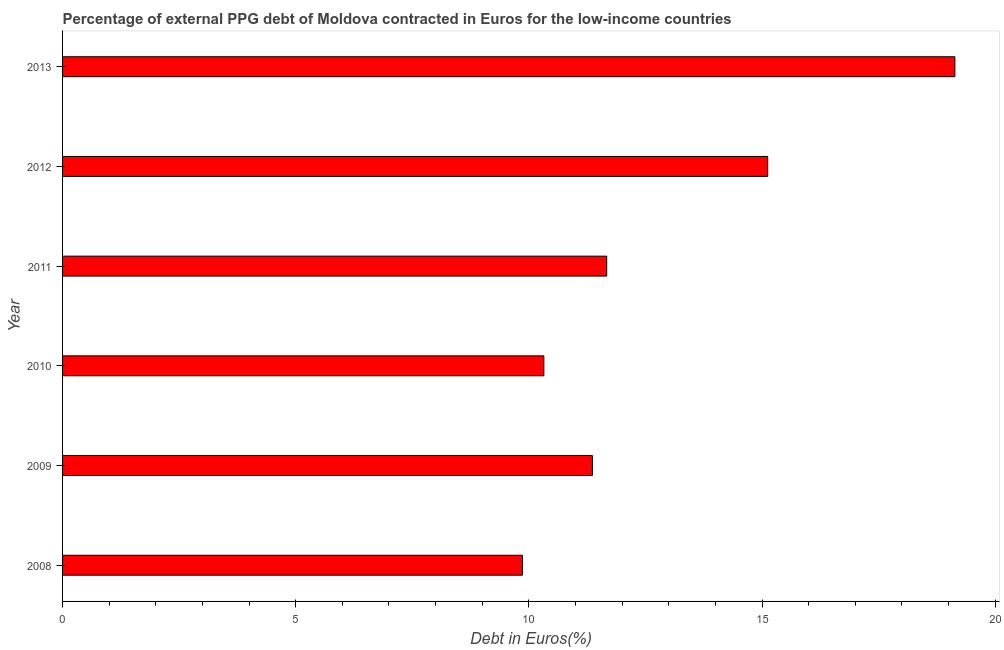Does the graph contain any zero values?
Your answer should be very brief. No. What is the title of the graph?
Your answer should be compact. Percentage of external PPG debt of Moldova contracted in Euros for the low-income countries. What is the label or title of the X-axis?
Offer a very short reply. Debt in Euros(%). What is the label or title of the Y-axis?
Keep it short and to the point. Year. What is the currency composition of ppg debt in 2009?
Offer a very short reply. 11.36. Across all years, what is the maximum currency composition of ppg debt?
Offer a very short reply. 19.14. Across all years, what is the minimum currency composition of ppg debt?
Keep it short and to the point. 9.86. What is the sum of the currency composition of ppg debt?
Your answer should be compact. 77.47. What is the difference between the currency composition of ppg debt in 2012 and 2013?
Offer a very short reply. -4.01. What is the average currency composition of ppg debt per year?
Keep it short and to the point. 12.91. What is the median currency composition of ppg debt?
Your answer should be compact. 11.52. Do a majority of the years between 2010 and 2013 (inclusive) have currency composition of ppg debt greater than 7 %?
Your answer should be compact. Yes. Is the currency composition of ppg debt in 2009 less than that in 2011?
Your response must be concise. Yes. What is the difference between the highest and the second highest currency composition of ppg debt?
Ensure brevity in your answer.  4.01. Is the sum of the currency composition of ppg debt in 2010 and 2012 greater than the maximum currency composition of ppg debt across all years?
Offer a very short reply. Yes. What is the difference between the highest and the lowest currency composition of ppg debt?
Your answer should be compact. 9.27. How many years are there in the graph?
Your response must be concise. 6. What is the Debt in Euros(%) of 2008?
Ensure brevity in your answer.  9.86. What is the Debt in Euros(%) in 2009?
Make the answer very short. 11.36. What is the Debt in Euros(%) of 2010?
Give a very brief answer. 10.32. What is the Debt in Euros(%) of 2011?
Your answer should be very brief. 11.67. What is the Debt in Euros(%) of 2012?
Your answer should be compact. 15.12. What is the Debt in Euros(%) of 2013?
Your answer should be very brief. 19.14. What is the difference between the Debt in Euros(%) in 2008 and 2009?
Provide a succinct answer. -1.5. What is the difference between the Debt in Euros(%) in 2008 and 2010?
Keep it short and to the point. -0.46. What is the difference between the Debt in Euros(%) in 2008 and 2011?
Give a very brief answer. -1.81. What is the difference between the Debt in Euros(%) in 2008 and 2012?
Give a very brief answer. -5.26. What is the difference between the Debt in Euros(%) in 2008 and 2013?
Make the answer very short. -9.27. What is the difference between the Debt in Euros(%) in 2009 and 2010?
Offer a very short reply. 1.04. What is the difference between the Debt in Euros(%) in 2009 and 2011?
Provide a succinct answer. -0.31. What is the difference between the Debt in Euros(%) in 2009 and 2012?
Offer a terse response. -3.76. What is the difference between the Debt in Euros(%) in 2009 and 2013?
Give a very brief answer. -7.77. What is the difference between the Debt in Euros(%) in 2010 and 2011?
Offer a terse response. -1.35. What is the difference between the Debt in Euros(%) in 2010 and 2012?
Offer a very short reply. -4.8. What is the difference between the Debt in Euros(%) in 2010 and 2013?
Ensure brevity in your answer.  -8.81. What is the difference between the Debt in Euros(%) in 2011 and 2012?
Your answer should be compact. -3.45. What is the difference between the Debt in Euros(%) in 2011 and 2013?
Give a very brief answer. -7.47. What is the difference between the Debt in Euros(%) in 2012 and 2013?
Your answer should be compact. -4.01. What is the ratio of the Debt in Euros(%) in 2008 to that in 2009?
Provide a short and direct response. 0.87. What is the ratio of the Debt in Euros(%) in 2008 to that in 2010?
Give a very brief answer. 0.95. What is the ratio of the Debt in Euros(%) in 2008 to that in 2011?
Your response must be concise. 0.84. What is the ratio of the Debt in Euros(%) in 2008 to that in 2012?
Your answer should be very brief. 0.65. What is the ratio of the Debt in Euros(%) in 2008 to that in 2013?
Provide a succinct answer. 0.52. What is the ratio of the Debt in Euros(%) in 2009 to that in 2010?
Offer a terse response. 1.1. What is the ratio of the Debt in Euros(%) in 2009 to that in 2012?
Offer a terse response. 0.75. What is the ratio of the Debt in Euros(%) in 2009 to that in 2013?
Provide a succinct answer. 0.59. What is the ratio of the Debt in Euros(%) in 2010 to that in 2011?
Give a very brief answer. 0.88. What is the ratio of the Debt in Euros(%) in 2010 to that in 2012?
Provide a succinct answer. 0.68. What is the ratio of the Debt in Euros(%) in 2010 to that in 2013?
Your answer should be compact. 0.54. What is the ratio of the Debt in Euros(%) in 2011 to that in 2012?
Ensure brevity in your answer.  0.77. What is the ratio of the Debt in Euros(%) in 2011 to that in 2013?
Give a very brief answer. 0.61. What is the ratio of the Debt in Euros(%) in 2012 to that in 2013?
Make the answer very short. 0.79. 